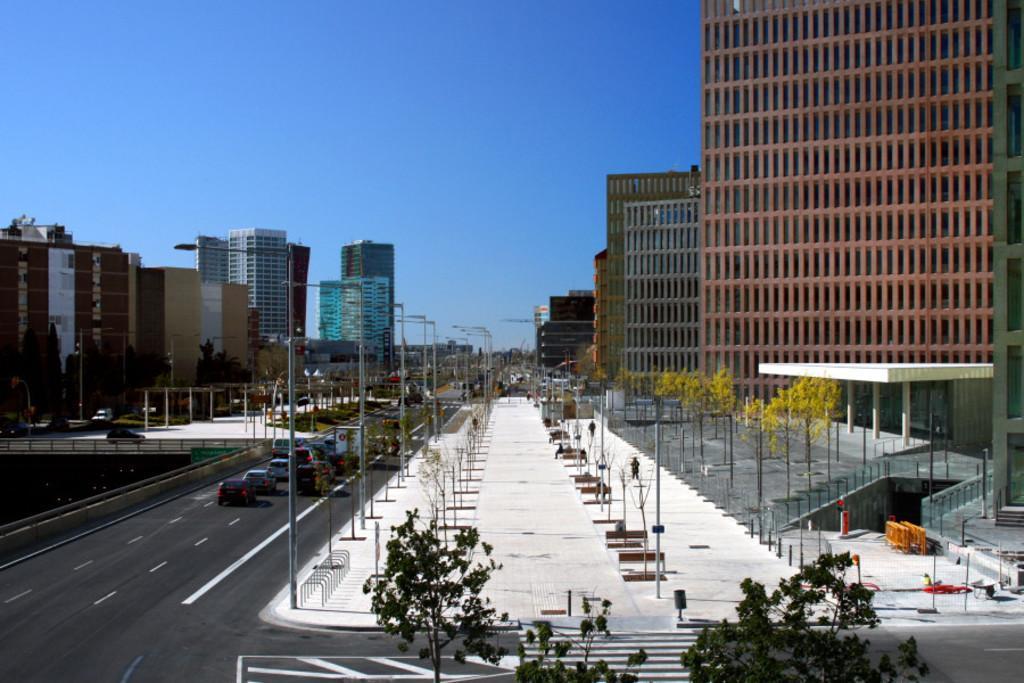How would you summarize this image in a sentence or two? We can see trees,poles and lights on poles and we can see vehicles on the road. In the background we can see buildings,trees and sky. 